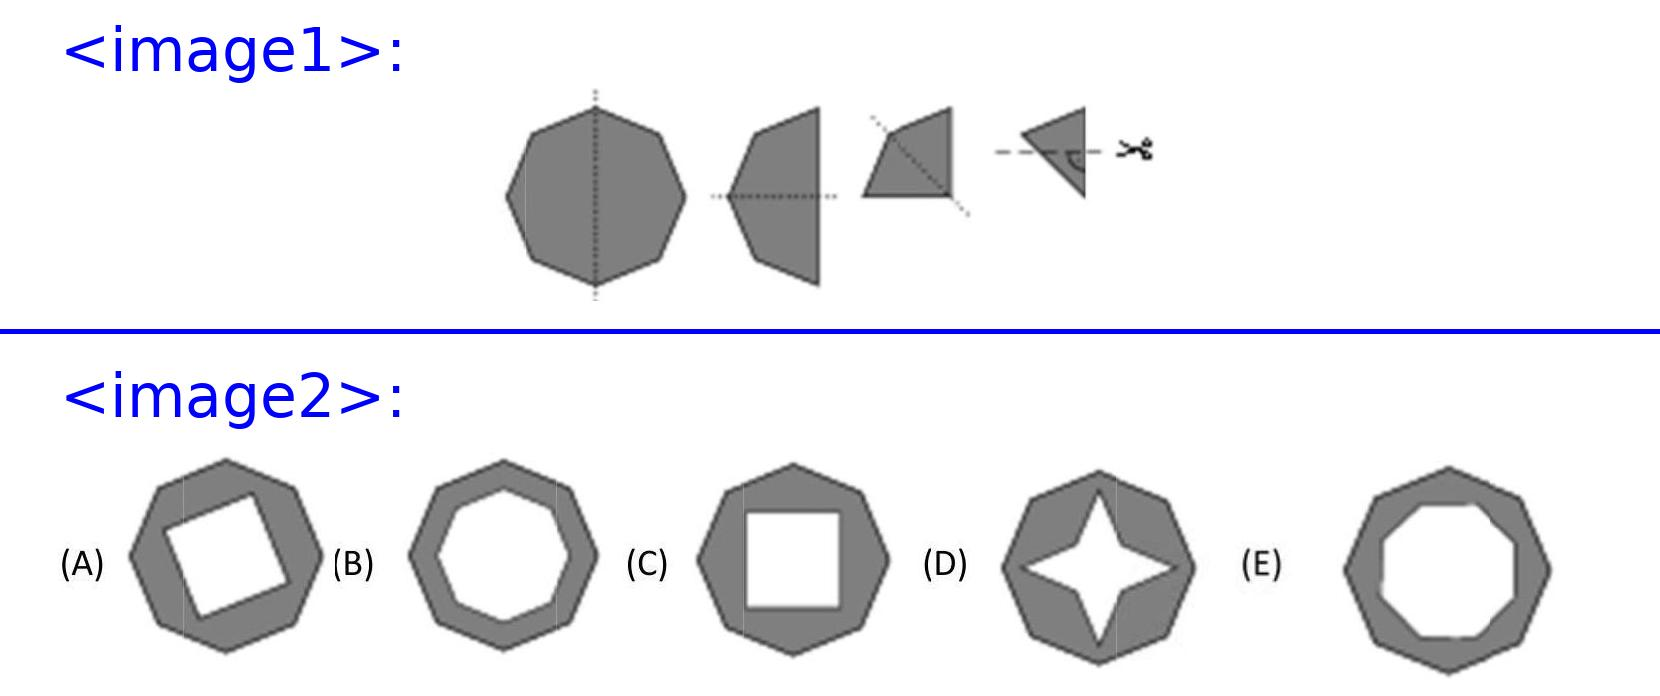Can you explain how each step of folding and cutting affects the final shape? Certainly! First, the octagon is folded in half three times, reducing its shape to one-eighth of its size as a triangle. Each fold creates a symmetry axis. When you cut the rightmost corner of this triangle, the cut is mirrored across each layer due to these folds. As you unfold the octagon, this singular triangular cut transforms into multiple symmetric cuts that form the pattern observed in option C, helping it attain a shape with each side appearing slightly concaved. 